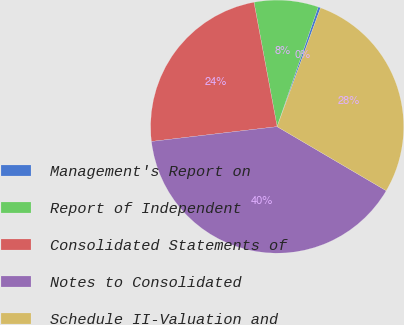Convert chart to OTSL. <chart><loc_0><loc_0><loc_500><loc_500><pie_chart><fcel>Management's Report on<fcel>Report of Independent<fcel>Consolidated Statements of<fcel>Notes to Consolidated<fcel>Schedule II-Valuation and<nl><fcel>0.32%<fcel>8.19%<fcel>23.94%<fcel>39.68%<fcel>27.87%<nl></chart> 